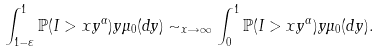Convert formula to latex. <formula><loc_0><loc_0><loc_500><loc_500>\int _ { 1 - \varepsilon } ^ { 1 } \mathbb { P } ( I > x y ^ { \alpha } ) y \mu _ { 0 } ( d y ) \sim _ { x \rightarrow \infty } \int _ { 0 } ^ { 1 } \mathbb { P } ( I > x y ^ { \alpha } ) y \mu _ { 0 } ( d y ) .</formula> 